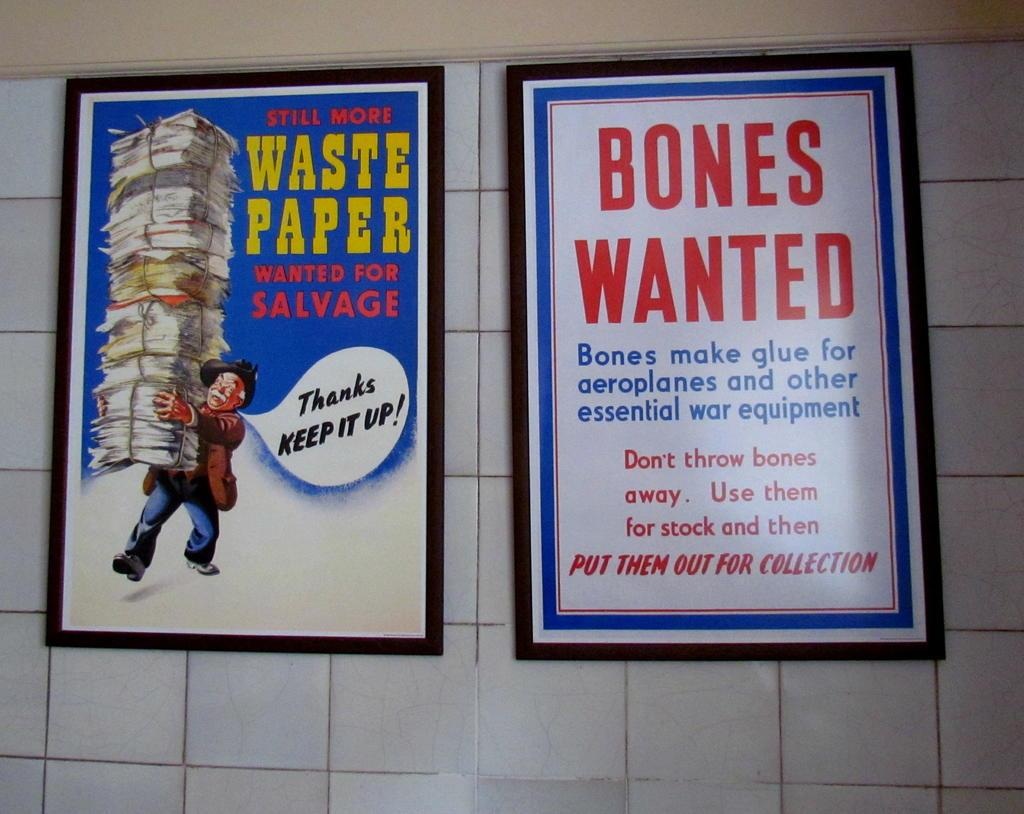<image>
Offer a succinct explanation of the picture presented. two ads in a subway for Waste Paper and Bones Wanted 